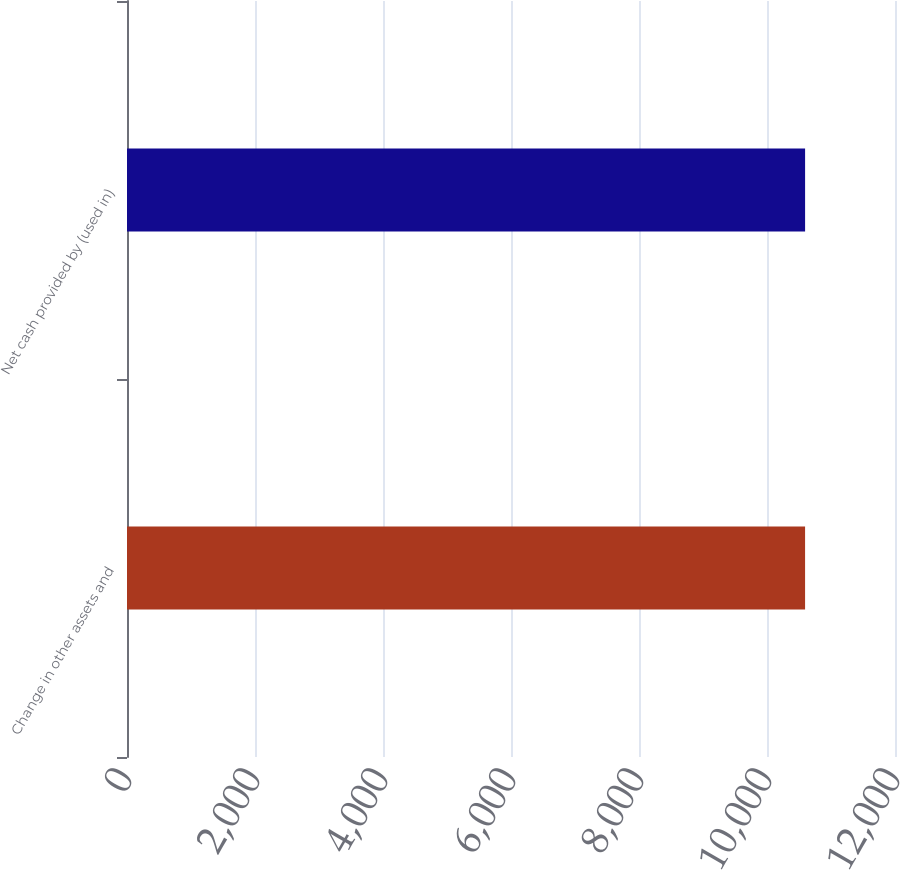Convert chart to OTSL. <chart><loc_0><loc_0><loc_500><loc_500><bar_chart><fcel>Change in other assets and<fcel>Net cash provided by (used in)<nl><fcel>10595<fcel>10595.2<nl></chart> 